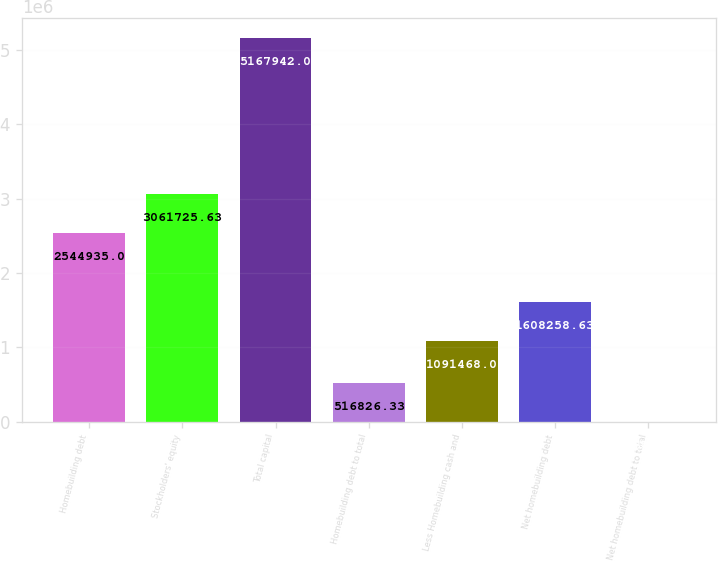Convert chart to OTSL. <chart><loc_0><loc_0><loc_500><loc_500><bar_chart><fcel>Homebuilding debt<fcel>Stockholders' equity<fcel>Total capital<fcel>Homebuilding debt to total<fcel>Less Homebuilding cash and<fcel>Net homebuilding debt<fcel>Net homebuilding debt to total<nl><fcel>2.54494e+06<fcel>3.06173e+06<fcel>5.16794e+06<fcel>516826<fcel>1.09147e+06<fcel>1.60826e+06<fcel>35.7<nl></chart> 